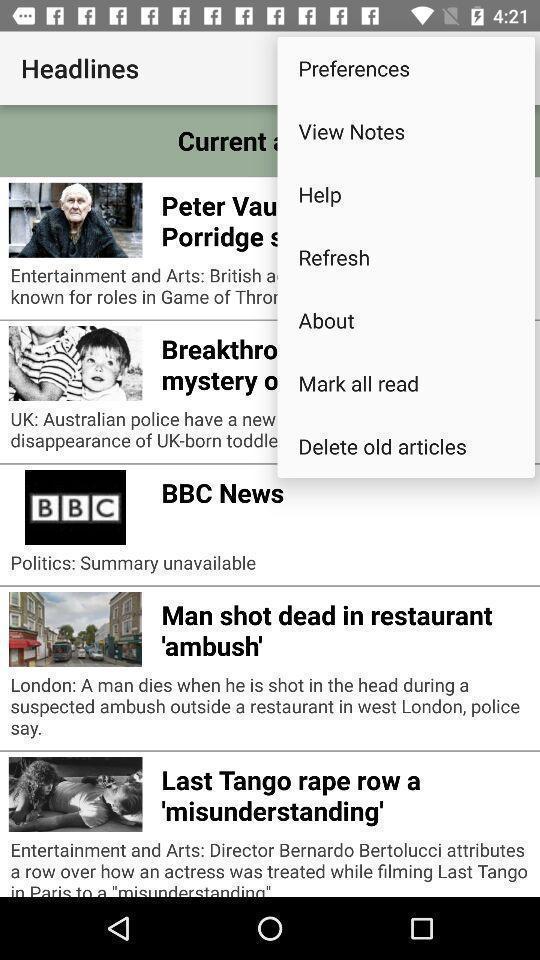Tell me what you see in this picture. Screen shows headlines in a news app. 